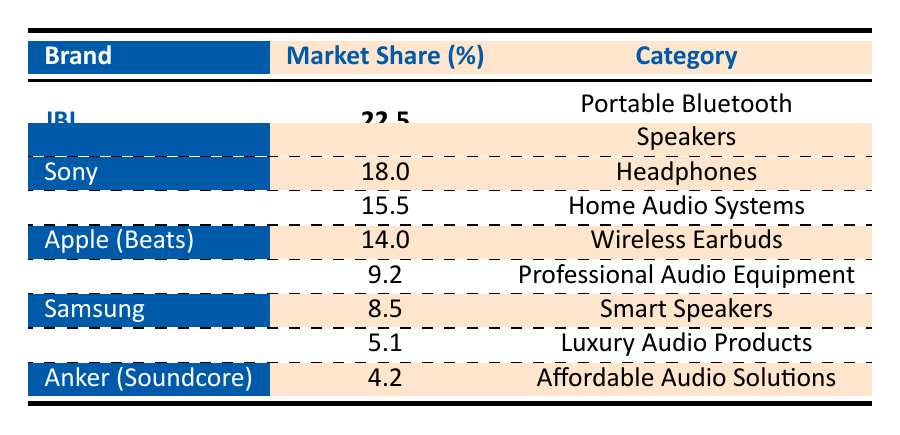What is the market share percentage of JBL? The table shows that JBL has a market share of 22.5%.
Answer: 22.5% Which brand has a higher market share, Sony or Bose? The table lists Sony with a market share of 18.0% and Bose with 15.5%. Since 18.0% is greater than 15.5%, Sony has a higher market share.
Answer: Sony What is the total market share percentage of all brands listed? To find the total market share percentage, we add the percentages of all brands: 22.5 + 18.0 + 15.5 + 14.0 + 9.2 + 8.5 + 5.1 + 4.2 =  97.0%.
Answer: 97.0% Is Apple (Beats) the second leading brand by market share? According to the table, Apple (Beats) has a market share of 14.0%. The leading brand is JBL (22.5%), followed by Sony (18.0%) and then Bose (15.5%). So, Apple (Beats) is not the second leading brand.
Answer: No What is the difference in market share between Sennheiser and Anker (Soundcore)? The market share for Sennheiser is 9.2% and for Anker (Soundcore) is 4.2%. To find the difference, subtract Anker's share from Sennheiser's: 9.2 - 4.2 = 5.0%.
Answer: 5.0% Which category does Bang & Olufsen represent? The table indicates that Bang & Olufsen is categorized as Luxury Audio Products.
Answer: Luxury Audio Products What brand has the least market share in this data? Looking at the table, Anker (Soundcore) has the lowest market share percentage at 4.2%.
Answer: Anker (Soundcore) What is the average market share of the brands listed in the table? To calculate the average market share, we sum the market shares (97.0%) and divide by the number of brands (8): 97.0 / 8 = 12.125%.
Answer: 12.125% 